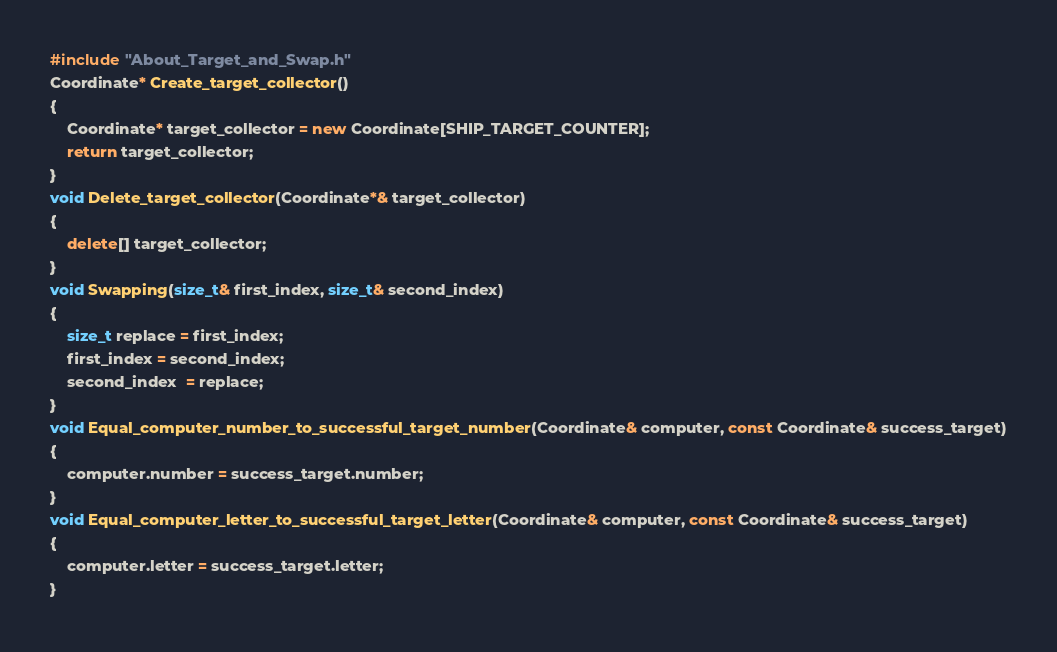Convert code to text. <code><loc_0><loc_0><loc_500><loc_500><_C++_>#include "About_Target_and_Swap.h"
Coordinate* Create_target_collector()
{
	Coordinate* target_collector = new Coordinate[SHIP_TARGET_COUNTER];
	return target_collector;
}
void Delete_target_collector(Coordinate*& target_collector)
{
	delete[] target_collector;
}
void Swapping(size_t& first_index, size_t& second_index)
{
	size_t replace = first_index;
	first_index = second_index;
    second_index  = replace;
}
void Equal_computer_number_to_successful_target_number(Coordinate& computer, const Coordinate& success_target)
{
	computer.number = success_target.number;
}
void Equal_computer_letter_to_successful_target_letter(Coordinate& computer, const Coordinate& success_target)
{
	computer.letter = success_target.letter;
}</code> 